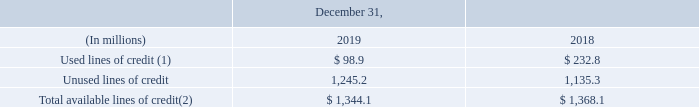Lines of Credit
The following table summarizes our available lines of credit and committed and uncommitted lines of credit, including the revolving credit facility discussed above, and the amounts available under our accounts receivable securitization programs.
(1) Includes total borrowings under the accounts receivable securitization programs, the revolving credit facility and borrowings under lines of credit available to several subsidiaries.
(2) Of the total available lines of credit, $1,137.4 million were committed as of December 31, 2019.
How much was commited as of December 31, 2019 of total available lines of credit? $1,137.4 million. What does the table show? Summarizes our available lines of credit and committed and uncommitted lines of credit, including the revolving credit facility discussed above, and the amounts available under our accounts receivable securitization programs. What years are included in the table? 2019, 2018. How much money has not been committed as of December 31, 2019 for total available lines of credit?
Answer scale should be: million. 1,344.1-1,137.4
Answer: 206.7. What is the percentage of used lines of credit to Total available lines of credit as of December 31, 2019?
Answer scale should be: percent. 98.9/1,344.1
Answer: 7.36. What is the difference between the Unused lines of credit for 2019 and 2018?
Answer scale should be: million. 1,245.2-1,135.3
Answer: 109.9. 